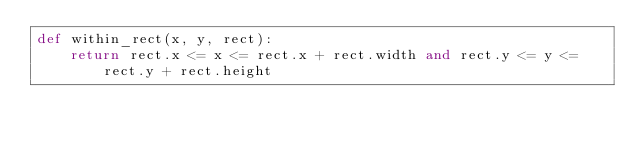<code> <loc_0><loc_0><loc_500><loc_500><_Python_>def within_rect(x, y, rect):
    return rect.x <= x <= rect.x + rect.width and rect.y <= y <= rect.y + rect.height
</code> 